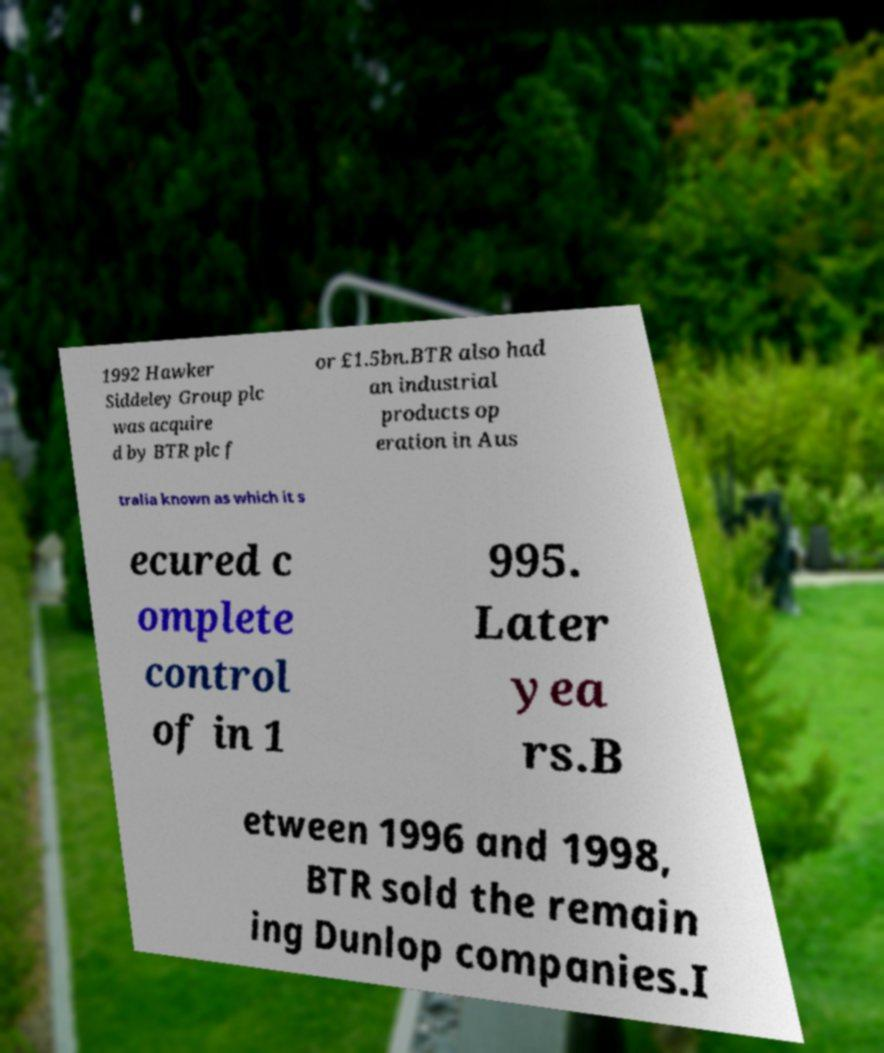I need the written content from this picture converted into text. Can you do that? 1992 Hawker Siddeley Group plc was acquire d by BTR plc f or £1.5bn.BTR also had an industrial products op eration in Aus tralia known as which it s ecured c omplete control of in 1 995. Later yea rs.B etween 1996 and 1998, BTR sold the remain ing Dunlop companies.I 